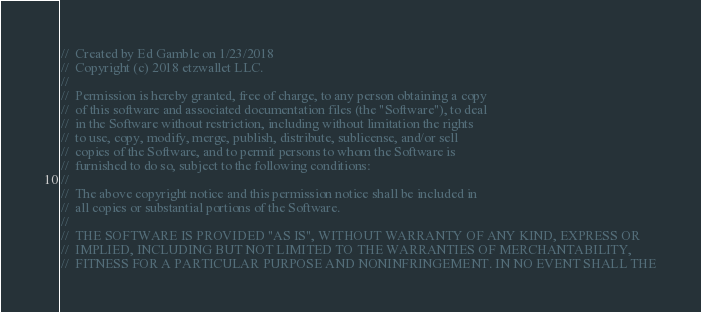<code> <loc_0><loc_0><loc_500><loc_500><_C_>//  Created by Ed Gamble on 1/23/2018
//  Copyright (c) 2018 etzwallet LLC.
//
//  Permission is hereby granted, free of charge, to any person obtaining a copy
//  of this software and associated documentation files (the "Software"), to deal
//  in the Software without restriction, including without limitation the rights
//  to use, copy, modify, merge, publish, distribute, sublicense, and/or sell
//  copies of the Software, and to permit persons to whom the Software is
//  furnished to do so, subject to the following conditions:
//
//  The above copyright notice and this permission notice shall be included in
//  all copies or substantial portions of the Software.
//
//  THE SOFTWARE IS PROVIDED "AS IS", WITHOUT WARRANTY OF ANY KIND, EXPRESS OR
//  IMPLIED, INCLUDING BUT NOT LIMITED TO THE WARRANTIES OF MERCHANTABILITY,
//  FITNESS FOR A PARTICULAR PURPOSE AND NONINFRINGEMENT. IN NO EVENT SHALL THE</code> 